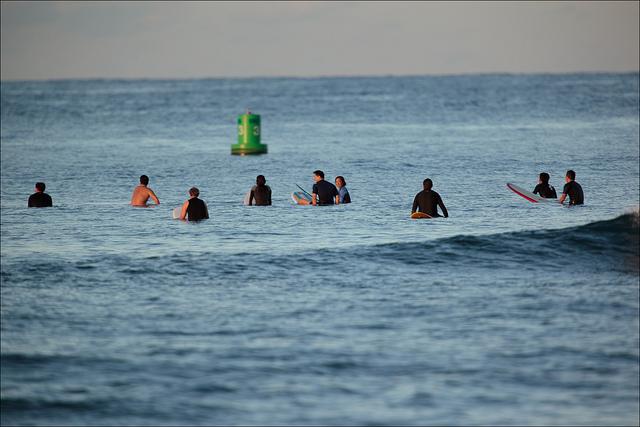How deep is the water?
Be succinct. 3 feet. What are these people waiting for?
Write a very short answer. Waves. What's the green object in the background?
Short answer required. Buoy. 